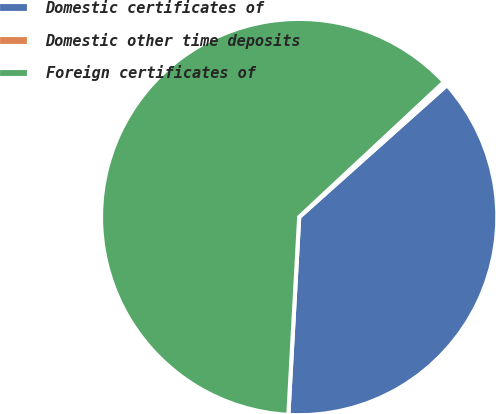Convert chart. <chart><loc_0><loc_0><loc_500><loc_500><pie_chart><fcel>Domestic certificates of<fcel>Domestic other time deposits<fcel>Foreign certificates of<nl><fcel>37.48%<fcel>0.34%<fcel>62.19%<nl></chart> 